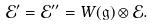Convert formula to latex. <formula><loc_0><loc_0><loc_500><loc_500>\mathcal { E } ^ { \prime } = \mathcal { E } ^ { \prime \prime } = W ( \mathfrak { g } ) \otimes \mathcal { E } .</formula> 